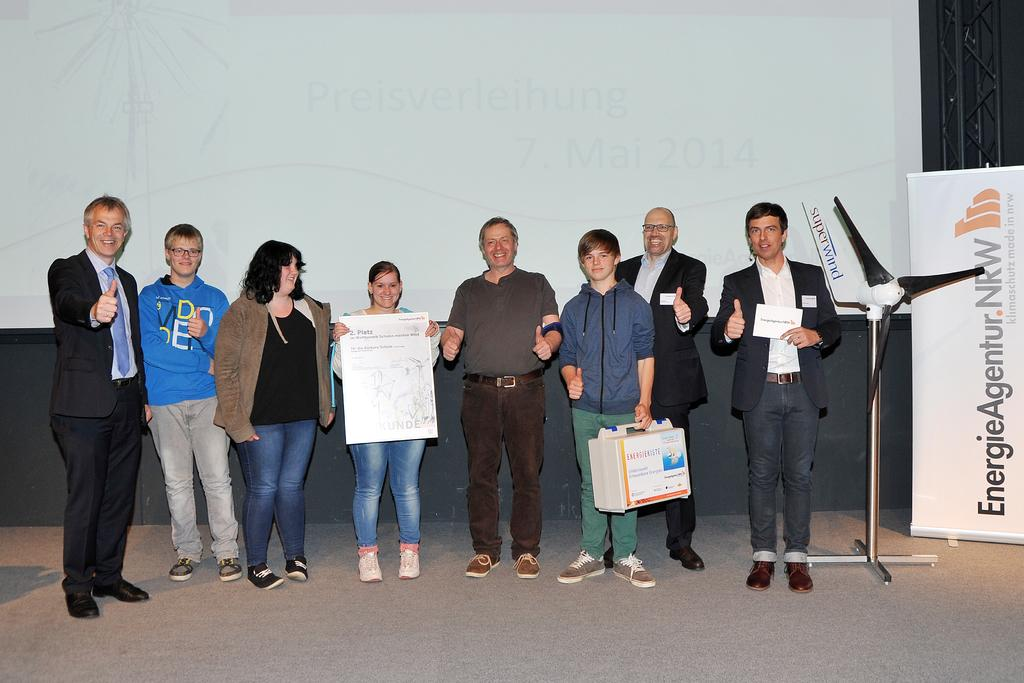How many people are in the image? There is a group of people in the image. What are the people in the image doing? The people are standing. What object can be seen providing air circulation in the image? There is a fan in the image. What type of structural elements are present in the image? Metal rods are present in the image. What type of signage is visible in the image? There is a hoarding in the image. What is located in the background of the image? There is a projector screen in the background of the image. What type of leather is being used to cover the snail in the image? There is no snail or leather present in the image. Can you tell me the name of the sister of one of the people in the image? There is no information about the people's siblings in the image. 